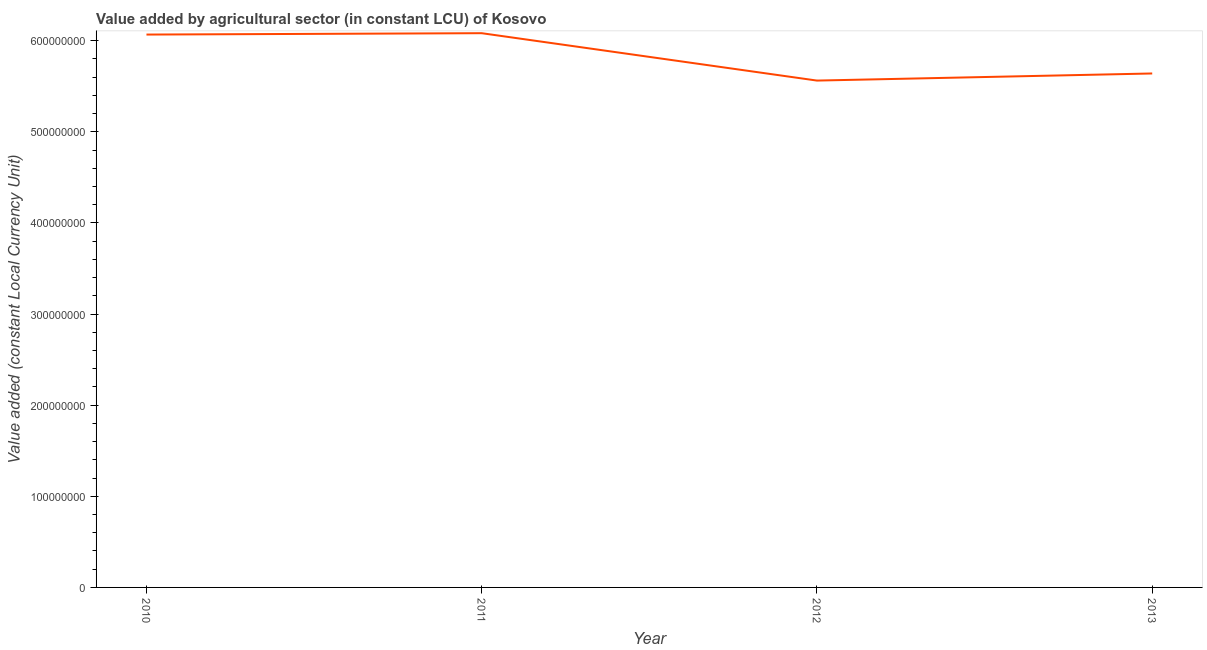What is the value added by agriculture sector in 2013?
Provide a short and direct response. 5.64e+08. Across all years, what is the maximum value added by agriculture sector?
Make the answer very short. 6.08e+08. Across all years, what is the minimum value added by agriculture sector?
Your answer should be very brief. 5.56e+08. In which year was the value added by agriculture sector maximum?
Keep it short and to the point. 2011. In which year was the value added by agriculture sector minimum?
Provide a short and direct response. 2012. What is the sum of the value added by agriculture sector?
Ensure brevity in your answer.  2.34e+09. What is the difference between the value added by agriculture sector in 2010 and 2011?
Give a very brief answer. -1.50e+06. What is the average value added by agriculture sector per year?
Provide a succinct answer. 5.84e+08. What is the median value added by agriculture sector?
Offer a terse response. 5.85e+08. In how many years, is the value added by agriculture sector greater than 320000000 LCU?
Make the answer very short. 4. What is the ratio of the value added by agriculture sector in 2011 to that in 2012?
Ensure brevity in your answer.  1.09. Is the value added by agriculture sector in 2011 less than that in 2013?
Provide a short and direct response. No. What is the difference between the highest and the second highest value added by agriculture sector?
Make the answer very short. 1.50e+06. What is the difference between the highest and the lowest value added by agriculture sector?
Offer a very short reply. 5.20e+07. Does the value added by agriculture sector monotonically increase over the years?
Provide a succinct answer. No. How many lines are there?
Offer a very short reply. 1. How many years are there in the graph?
Your answer should be compact. 4. What is the difference between two consecutive major ticks on the Y-axis?
Your response must be concise. 1.00e+08. What is the title of the graph?
Your response must be concise. Value added by agricultural sector (in constant LCU) of Kosovo. What is the label or title of the X-axis?
Ensure brevity in your answer.  Year. What is the label or title of the Y-axis?
Offer a very short reply. Value added (constant Local Currency Unit). What is the Value added (constant Local Currency Unit) of 2010?
Your answer should be very brief. 6.07e+08. What is the Value added (constant Local Currency Unit) in 2011?
Keep it short and to the point. 6.08e+08. What is the Value added (constant Local Currency Unit) of 2012?
Give a very brief answer. 5.56e+08. What is the Value added (constant Local Currency Unit) of 2013?
Offer a very short reply. 5.64e+08. What is the difference between the Value added (constant Local Currency Unit) in 2010 and 2011?
Make the answer very short. -1.50e+06. What is the difference between the Value added (constant Local Currency Unit) in 2010 and 2012?
Provide a succinct answer. 5.05e+07. What is the difference between the Value added (constant Local Currency Unit) in 2010 and 2013?
Provide a short and direct response. 4.27e+07. What is the difference between the Value added (constant Local Currency Unit) in 2011 and 2012?
Your answer should be compact. 5.20e+07. What is the difference between the Value added (constant Local Currency Unit) in 2011 and 2013?
Ensure brevity in your answer.  4.42e+07. What is the difference between the Value added (constant Local Currency Unit) in 2012 and 2013?
Offer a very short reply. -7.80e+06. What is the ratio of the Value added (constant Local Currency Unit) in 2010 to that in 2011?
Your answer should be compact. 1. What is the ratio of the Value added (constant Local Currency Unit) in 2010 to that in 2012?
Your answer should be very brief. 1.09. What is the ratio of the Value added (constant Local Currency Unit) in 2010 to that in 2013?
Provide a succinct answer. 1.08. What is the ratio of the Value added (constant Local Currency Unit) in 2011 to that in 2012?
Offer a very short reply. 1.09. What is the ratio of the Value added (constant Local Currency Unit) in 2011 to that in 2013?
Keep it short and to the point. 1.08. What is the ratio of the Value added (constant Local Currency Unit) in 2012 to that in 2013?
Give a very brief answer. 0.99. 